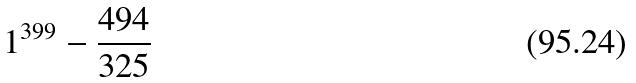Convert formula to latex. <formula><loc_0><loc_0><loc_500><loc_500>1 ^ { 3 9 9 } - \frac { 4 9 4 } { 3 2 5 }</formula> 